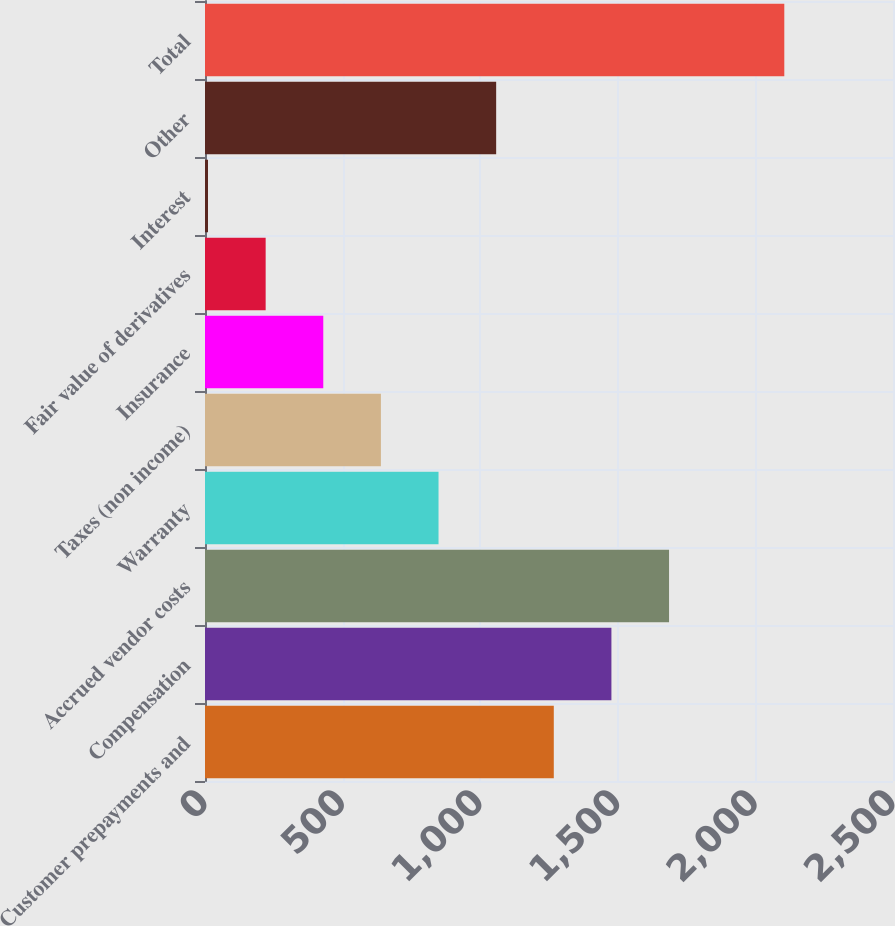Convert chart to OTSL. <chart><loc_0><loc_0><loc_500><loc_500><bar_chart><fcel>Customer prepayments and<fcel>Compensation<fcel>Accrued vendor costs<fcel>Warranty<fcel>Taxes (non income)<fcel>Insurance<fcel>Fair value of derivatives<fcel>Interest<fcel>Other<fcel>Total<nl><fcel>1267.4<fcel>1476.8<fcel>1686.2<fcel>848.6<fcel>639.2<fcel>429.8<fcel>220.4<fcel>11<fcel>1058<fcel>2105<nl></chart> 